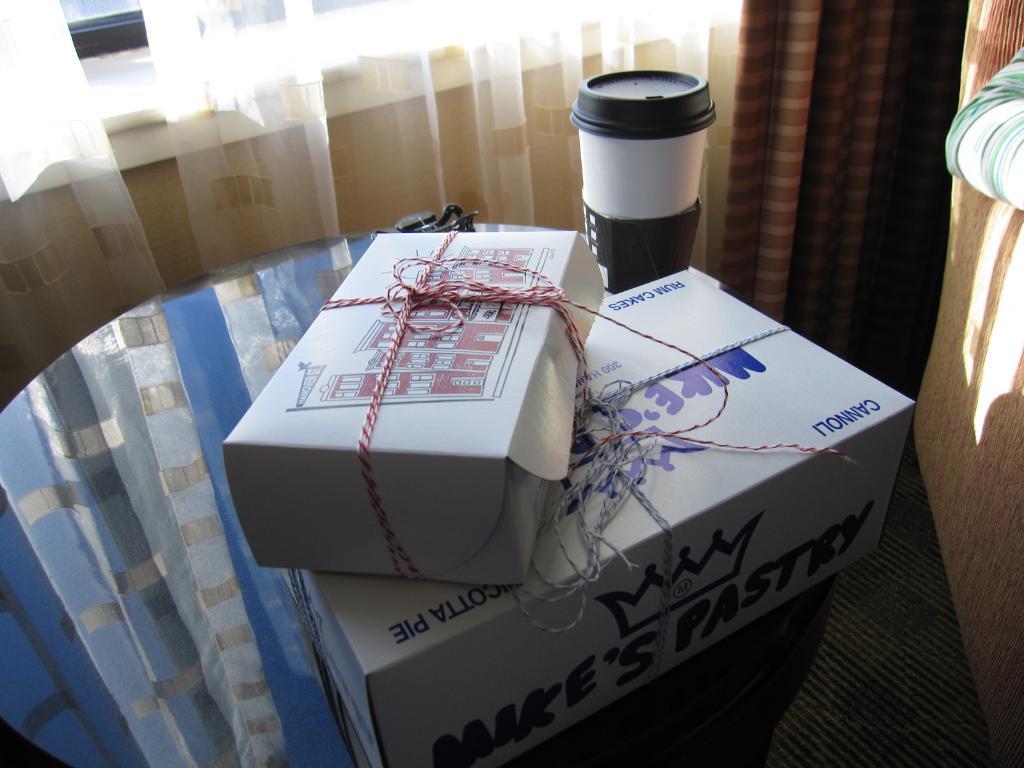Whos pastries are in the white box?
Offer a terse response. Mike's. What is inside the box?
Your response must be concise. Mike's pastry. 